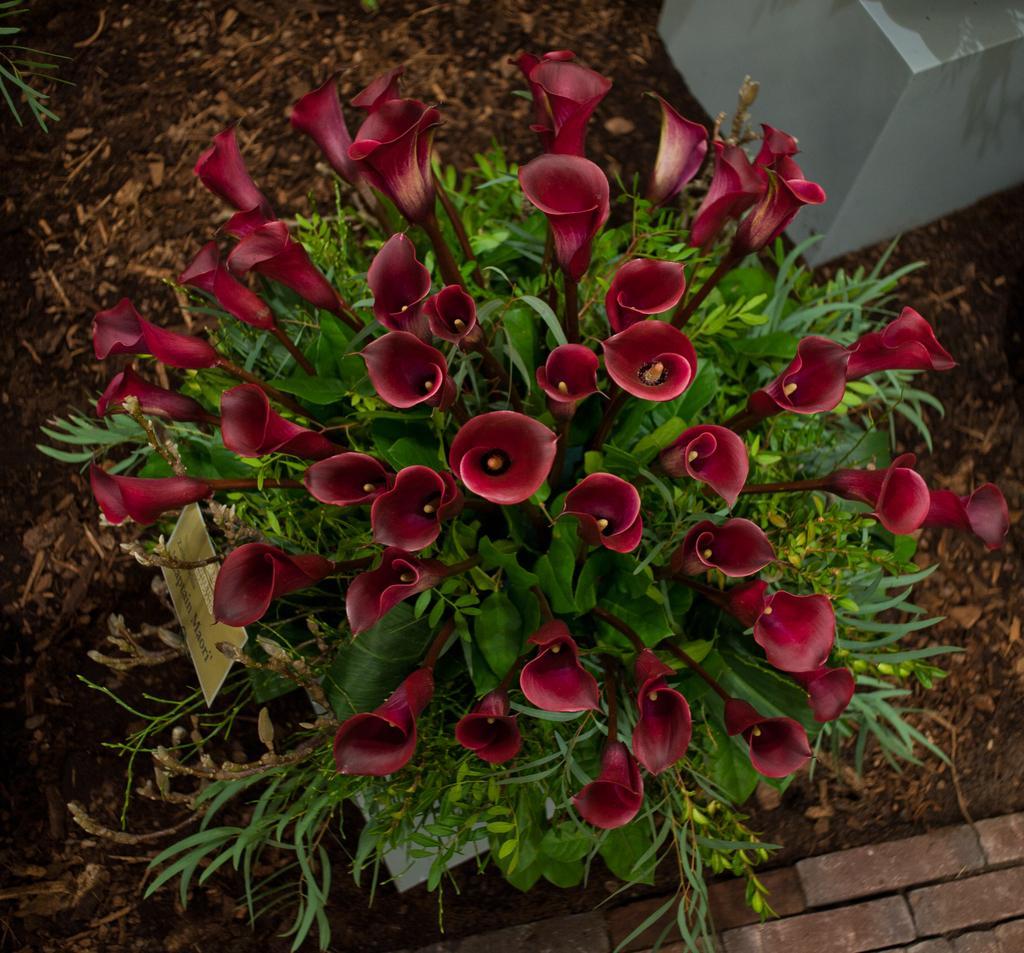Describe this image in one or two sentences. In this image I can see few flowers which are red in color to a tree which is green in color and I can see a board which is cream in color to the tree. In the background I can see the white colored object and the ground. 